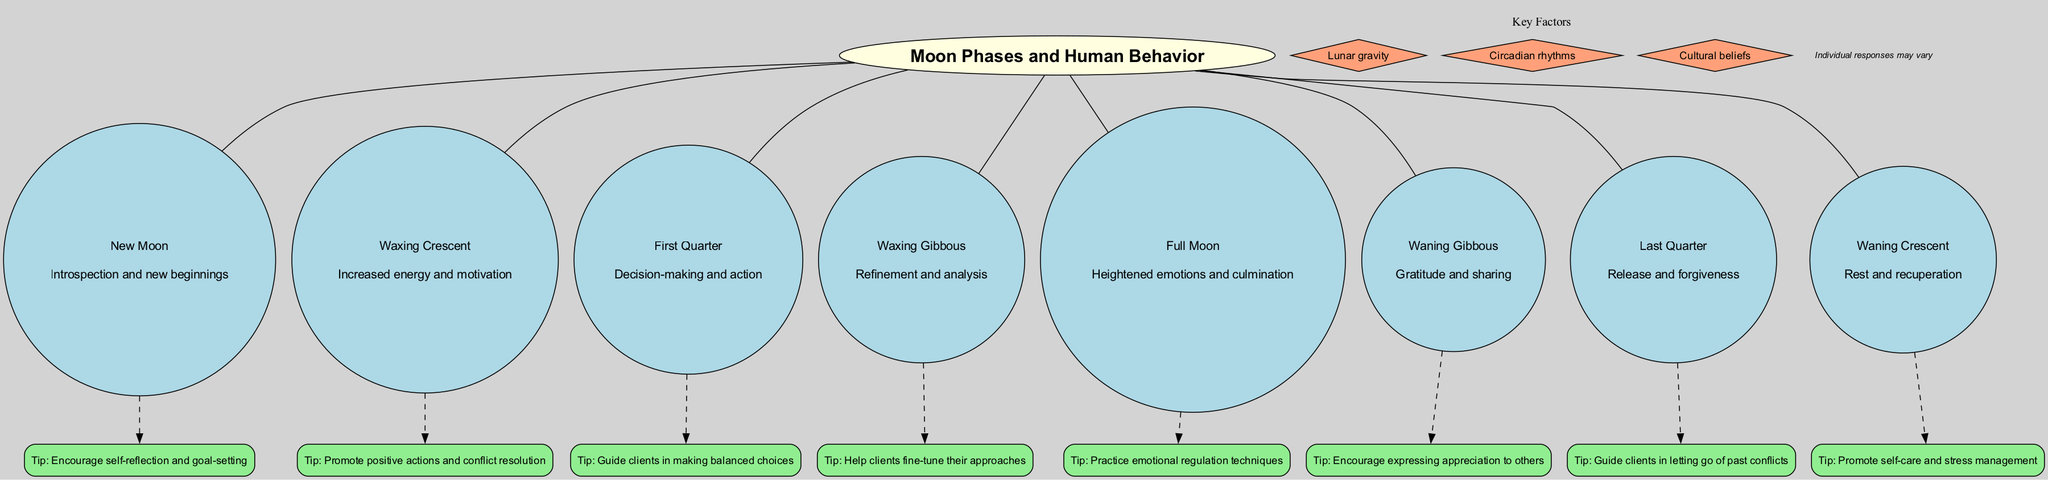What is the influence of the Full Moon phase? The diagram shows that the influence of the Full Moon is "Heightened emotions and culmination." This information is directly labeled next to the Full Moon node in the diagram.
Answer: Heightened emotions and culmination How many phases are listed in the diagram? By counting the individual nodes representing each moon phase, there are a total of eight phases displayed.
Answer: Eight What counseling tip is associated with the Waxing Crescent phase? The diagram indicates that the counseling tip linked to the Waxing Crescent is "Promote positive actions and conflict resolution." This information is connected to the Waxing Crescent node.
Answer: Promote positive actions and conflict resolution What key factors are included in the diagram? The diagram lists "Lunar gravity," "Circadian rhythms," and "Cultural beliefs" as the key factors, shown in the subgraph labeled 'Key Factors.'
Answer: Lunar gravity, Circadian rhythms, Cultural beliefs Which moon phase encourages self-reflection and goal-setting? The diagram clearly indicates that the New Moon phase is associated with the influence of "Introspection and new beginnings," which encourages self-reflection and goal-setting.
Answer: New Moon In what phase should clients be guided to make balanced choices? According to the diagram, during the First Quarter phase, clients should be guided to make balanced choices, as it is specifically mentioned next to the First Quarter node.
Answer: First Quarter What is the primary influence of the Waning Crescent phase? The diagram states that the Waning Crescent phase is associated with "Rest and recuperation," indicating its influence on human behavior.
Answer: Rest and recuperation During which phase is gratitude and sharing promoted? The diagram denotes that during the Waning Gibbous phase, the influence is "Gratitude and sharing," which triggers this behavior in people.
Answer: Waning Gibbous 